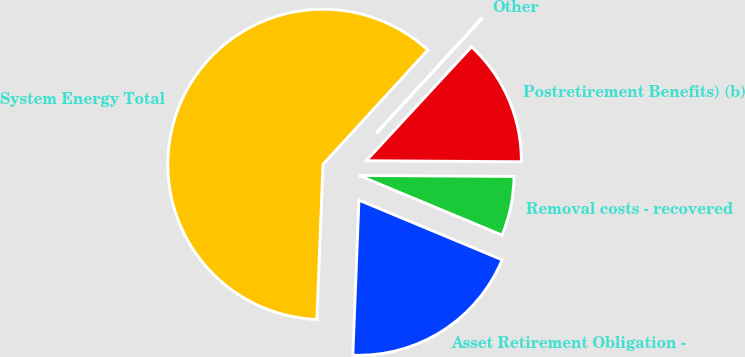<chart> <loc_0><loc_0><loc_500><loc_500><pie_chart><fcel>Asset Retirement Obligation -<fcel>Removal costs - recovered<fcel>Postretirement Benefits) (b)<fcel>Other<fcel>System Energy Total<nl><fcel>19.34%<fcel>6.18%<fcel>13.23%<fcel>0.07%<fcel>61.17%<nl></chart> 